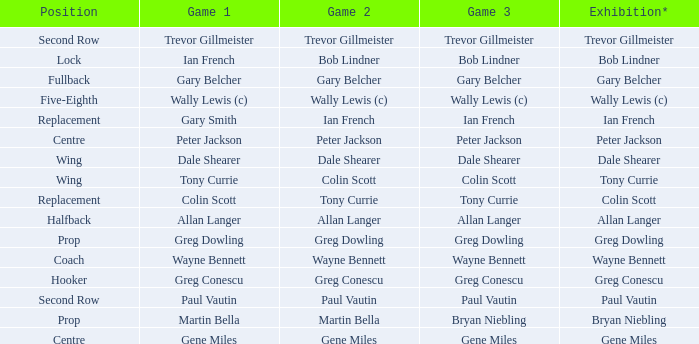What game 1 has bob lindner as game 2? Ian French. Give me the full table as a dictionary. {'header': ['Position', 'Game 1', 'Game 2', 'Game 3', 'Exhibition*'], 'rows': [['Second Row', 'Trevor Gillmeister', 'Trevor Gillmeister', 'Trevor Gillmeister', 'Trevor Gillmeister'], ['Lock', 'Ian French', 'Bob Lindner', 'Bob Lindner', 'Bob Lindner'], ['Fullback', 'Gary Belcher', 'Gary Belcher', 'Gary Belcher', 'Gary Belcher'], ['Five-Eighth', 'Wally Lewis (c)', 'Wally Lewis (c)', 'Wally Lewis (c)', 'Wally Lewis (c)'], ['Replacement', 'Gary Smith', 'Ian French', 'Ian French', 'Ian French'], ['Centre', 'Peter Jackson', 'Peter Jackson', 'Peter Jackson', 'Peter Jackson'], ['Wing', 'Dale Shearer', 'Dale Shearer', 'Dale Shearer', 'Dale Shearer'], ['Wing', 'Tony Currie', 'Colin Scott', 'Colin Scott', 'Tony Currie'], ['Replacement', 'Colin Scott', 'Tony Currie', 'Tony Currie', 'Colin Scott'], ['Halfback', 'Allan Langer', 'Allan Langer', 'Allan Langer', 'Allan Langer'], ['Prop', 'Greg Dowling', 'Greg Dowling', 'Greg Dowling', 'Greg Dowling'], ['Coach', 'Wayne Bennett', 'Wayne Bennett', 'Wayne Bennett', 'Wayne Bennett'], ['Hooker', 'Greg Conescu', 'Greg Conescu', 'Greg Conescu', 'Greg Conescu'], ['Second Row', 'Paul Vautin', 'Paul Vautin', 'Paul Vautin', 'Paul Vautin'], ['Prop', 'Martin Bella', 'Martin Bella', 'Bryan Niebling', 'Bryan Niebling'], ['Centre', 'Gene Miles', 'Gene Miles', 'Gene Miles', 'Gene Miles']]} 